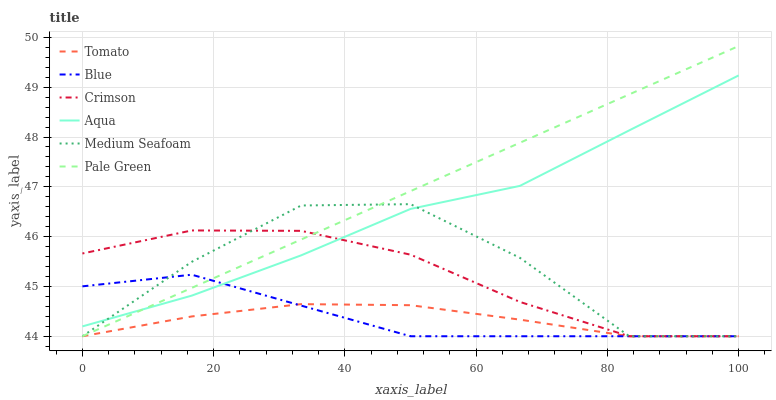Does Tomato have the minimum area under the curve?
Answer yes or no. Yes. Does Pale Green have the maximum area under the curve?
Answer yes or no. Yes. Does Blue have the minimum area under the curve?
Answer yes or no. No. Does Blue have the maximum area under the curve?
Answer yes or no. No. Is Pale Green the smoothest?
Answer yes or no. Yes. Is Medium Seafoam the roughest?
Answer yes or no. Yes. Is Blue the smoothest?
Answer yes or no. No. Is Blue the roughest?
Answer yes or no. No. Does Tomato have the lowest value?
Answer yes or no. Yes. Does Aqua have the lowest value?
Answer yes or no. No. Does Pale Green have the highest value?
Answer yes or no. Yes. Does Blue have the highest value?
Answer yes or no. No. Is Tomato less than Aqua?
Answer yes or no. Yes. Is Aqua greater than Tomato?
Answer yes or no. Yes. Does Medium Seafoam intersect Pale Green?
Answer yes or no. Yes. Is Medium Seafoam less than Pale Green?
Answer yes or no. No. Is Medium Seafoam greater than Pale Green?
Answer yes or no. No. Does Tomato intersect Aqua?
Answer yes or no. No. 